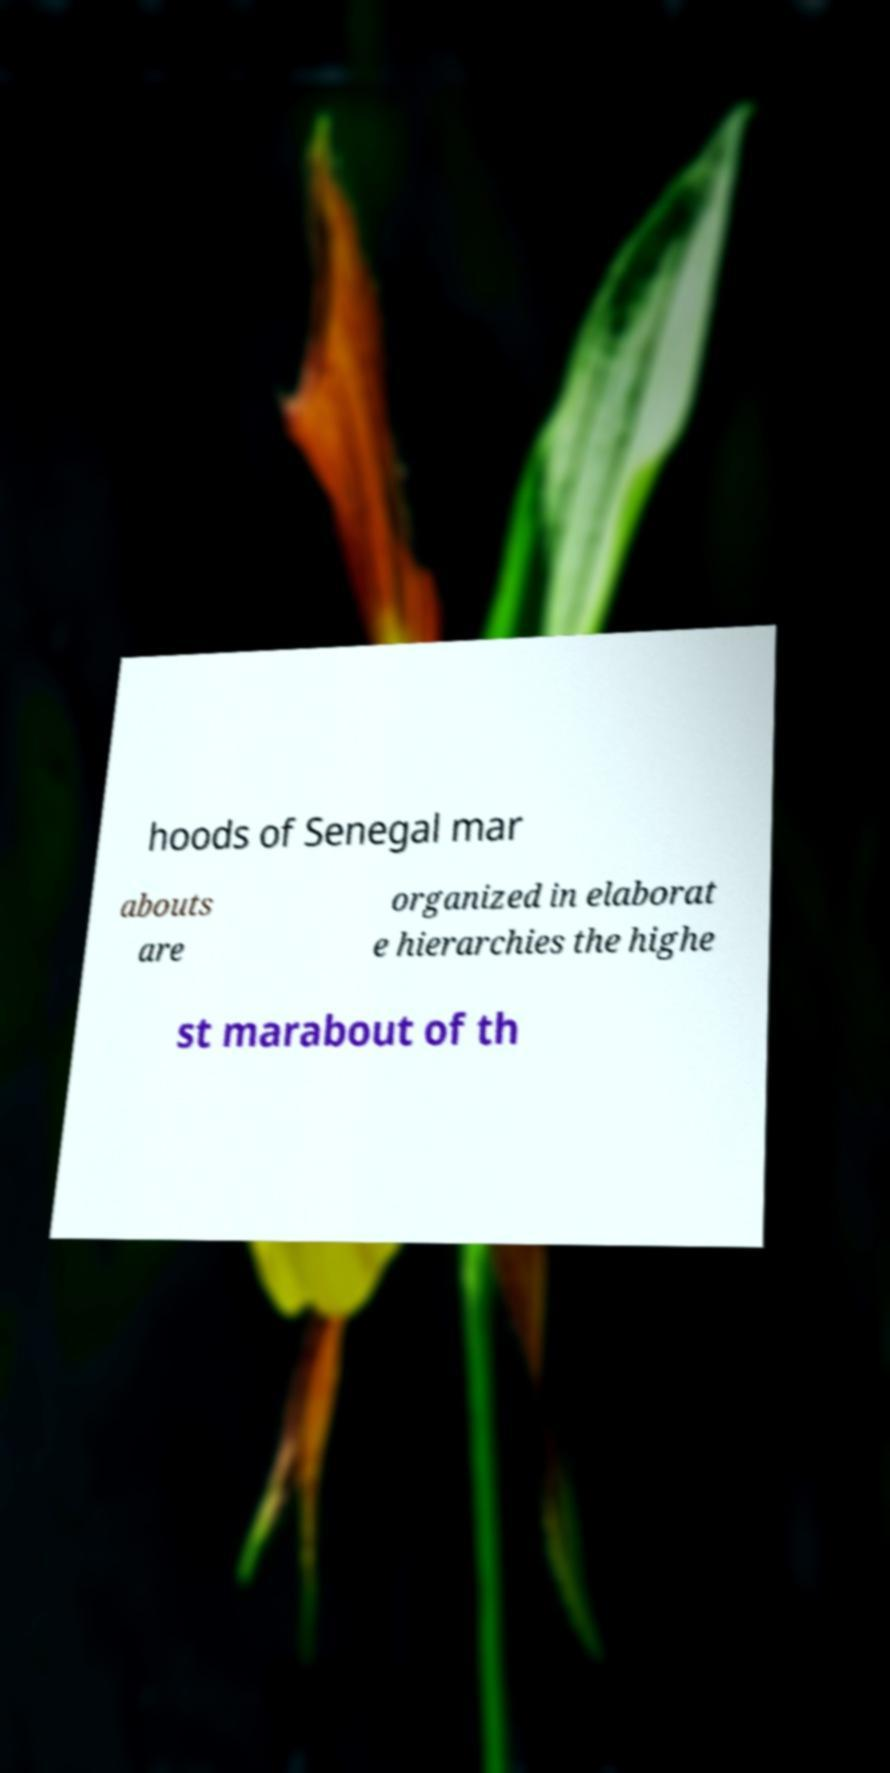What messages or text are displayed in this image? I need them in a readable, typed format. hoods of Senegal mar abouts are organized in elaborat e hierarchies the highe st marabout of th 